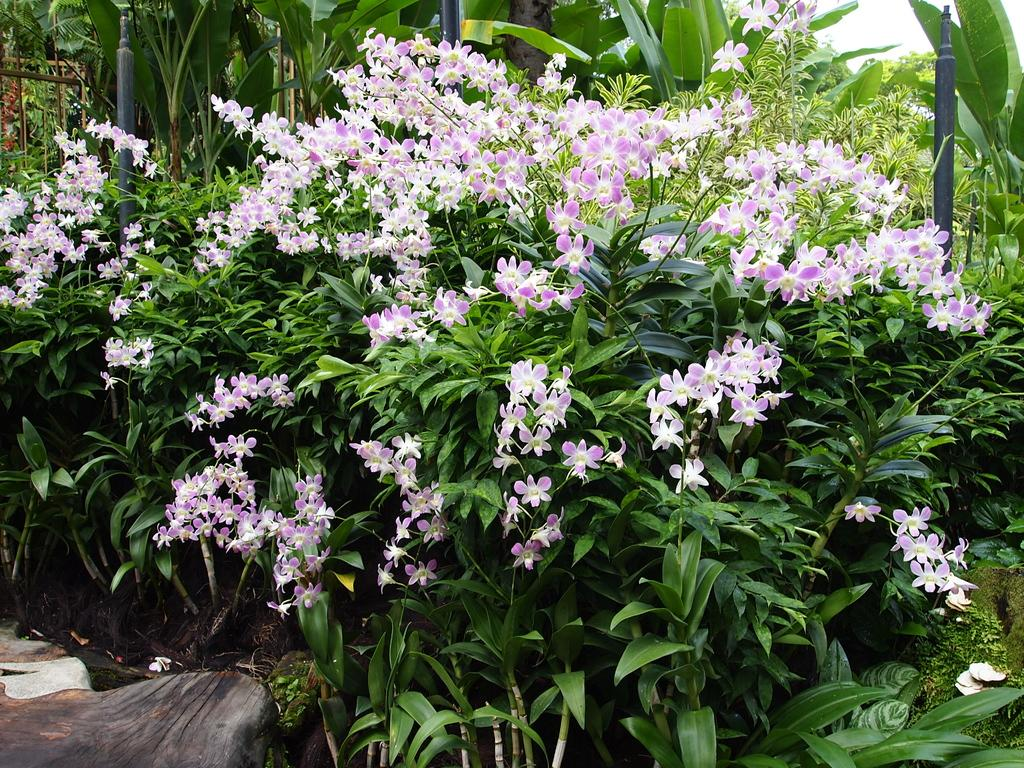What type of flora can be seen in the image? There are flowers and plants in the image. Can you describe the background of the image? There are trees in the background of the image. How does the flower maintain its balance in the image? The flower does not need to maintain its balance in the image, as it is a static object. 